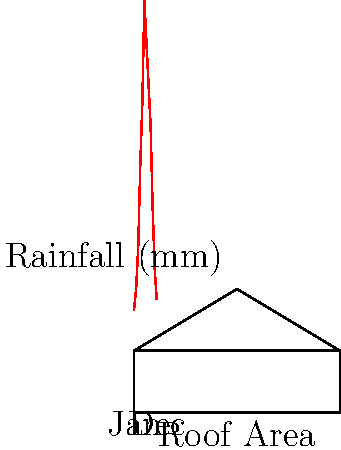A cost-conscious engineering student wants to design a rainwater harvesting system for their home. The roof area is 100 m², and the annual rainfall data is shown in the graph. If the student wants to collect 80% of the total annual rainfall and the water storage tank costs $0.5 per liter, what is the minimum cost for the storage tank? Assume 1 mm of rainfall over 1 m² yields 1 liter of water. To solve this problem, we'll follow these steps:

1. Calculate the total annual rainfall:
   Sum of monthly rainfall = 50 + 60 + 80 + 120 + 150 + 200 + 180 + 160 + 140 + 100 + 70 + 55 = 1365 mm

2. Calculate the total water collected annually:
   $$\text{Total water} = \text{Roof area} \times \text{Annual rainfall}$$
   $$\text{Total water} = 100 \text{ m}^2 \times 1365 \text{ mm} = 136,500 \text{ liters}$$

3. Calculate 80% of the total water collected:
   $$\text{Collected water} = 80\% \times 136,500 \text{ liters} = 109,200 \text{ liters}$$

4. Calculate the cost of the storage tank:
   $$\text{Cost} = \text{Collected water} \times \text{Cost per liter}$$
   $$\text{Cost} = 109,200 \text{ liters} \times \$0.5/\text{liter} = \$54,600$$

Therefore, the minimum cost for the storage tank is $54,600.
Answer: $54,600 